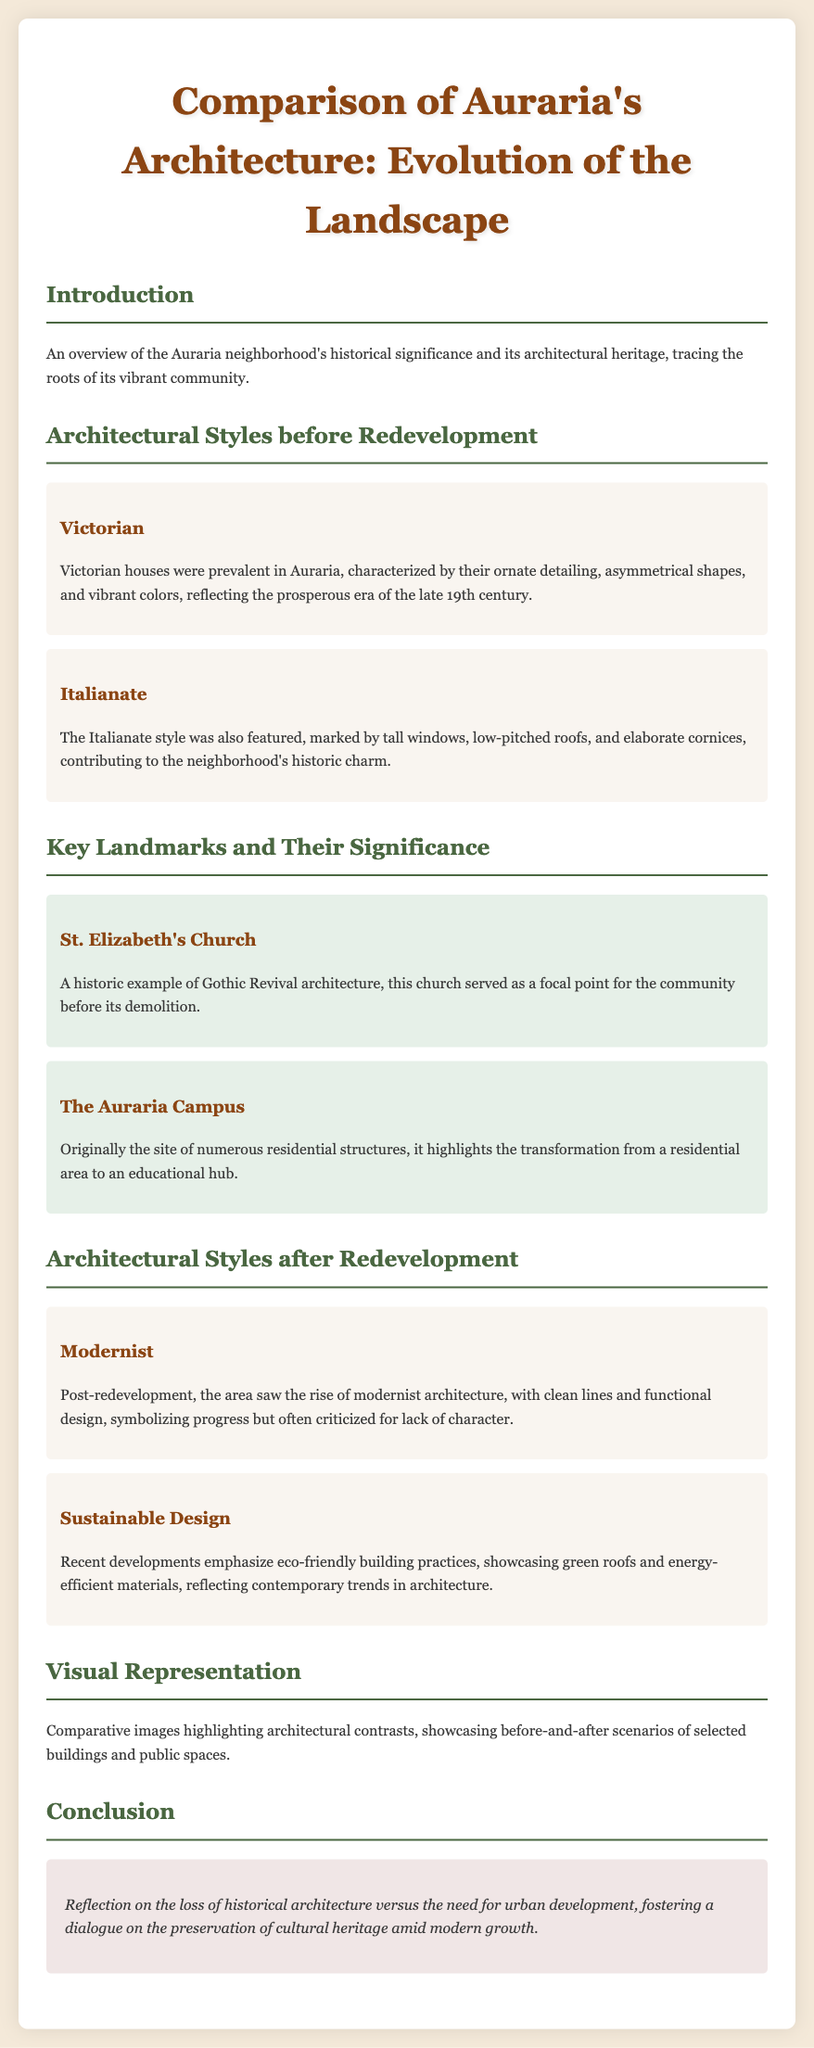what architectural style was prevalent in Auraria before redevelopment? The document states that Victorian houses were prevalent in Auraria, signifying its characteristic style before redevelopment.
Answer: Victorian what landmark is described as a historic example of Gothic Revival architecture? St. Elizabeth's Church is identified as a historic example of Gothic Revival architecture, highlighting its significance.
Answer: St. Elizabeth's Church what is a characteristic of the Italianate style? Features such as tall windows and low-pitched roofs are indicative of the Italianate style mentioned in the document.
Answer: Tall windows what architectural style emerged after redevelopment? The document mentions that modernist architecture is a style that became prominent in Auraria after redevelopment.
Answer: Modernist how does recent architecture emphasize sustainability? The document states that recent developments focus on eco-friendly practices, which indicates the trend towards sustainability in architecture.
Answer: Eco-friendly building practices what was the main focus of the Auraria Campus before its transformation? The document explains that the Auraria Campus was originally the site of numerous residential structures before its conversion.
Answer: Residential structures what type of images are included in the visual representation section? The visual representation section includes comparative images that highlight architectural contrasts before and after redevelopment.
Answer: Comparative images how does the conclusion reflect on Auraria's transformation? The conclusion discusses the loss of historical architecture versus urban development, fostering a dialogue on cultural heritage preservation.
Answer: Loss of historical architecture what is highlighted as a recent trend in building materials? The use of energy-efficient materials is mentioned as a recent trend in sustainable architecture in the document.
Answer: Energy-efficient materials 